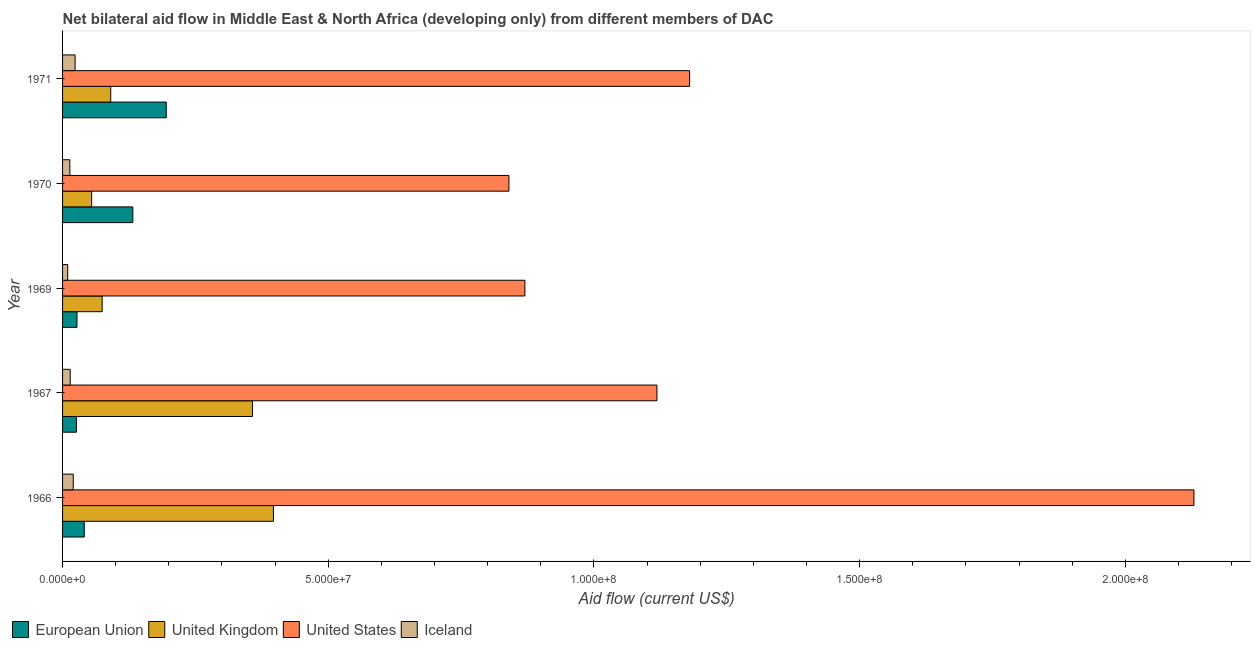How many groups of bars are there?
Make the answer very short. 5. Are the number of bars on each tick of the Y-axis equal?
Give a very brief answer. Yes. What is the label of the 2nd group of bars from the top?
Your answer should be compact. 1970. What is the amount of aid given by iceland in 1966?
Your answer should be compact. 2.01e+06. Across all years, what is the maximum amount of aid given by iceland?
Your answer should be compact. 2.36e+06. Across all years, what is the minimum amount of aid given by uk?
Your response must be concise. 5.47e+06. What is the total amount of aid given by us in the graph?
Provide a short and direct response. 6.14e+08. What is the difference between the amount of aid given by us in 1967 and that in 1969?
Give a very brief answer. 2.48e+07. What is the difference between the amount of aid given by us in 1969 and the amount of aid given by eu in 1971?
Your answer should be very brief. 6.75e+07. What is the average amount of aid given by us per year?
Ensure brevity in your answer.  1.23e+08. In the year 1971, what is the difference between the amount of aid given by uk and amount of aid given by eu?
Your answer should be compact. -1.04e+07. What is the ratio of the amount of aid given by uk in 1967 to that in 1969?
Offer a terse response. 4.8. Is the difference between the amount of aid given by eu in 1967 and 1970 greater than the difference between the amount of aid given by iceland in 1967 and 1970?
Offer a very short reply. No. What is the difference between the highest and the second highest amount of aid given by us?
Provide a succinct answer. 9.49e+07. What is the difference between the highest and the lowest amount of aid given by iceland?
Ensure brevity in your answer.  1.39e+06. Is it the case that in every year, the sum of the amount of aid given by eu and amount of aid given by uk is greater than the sum of amount of aid given by us and amount of aid given by iceland?
Your answer should be very brief. Yes. Is it the case that in every year, the sum of the amount of aid given by eu and amount of aid given by uk is greater than the amount of aid given by us?
Your answer should be very brief. No. How many bars are there?
Provide a succinct answer. 20. How are the legend labels stacked?
Provide a short and direct response. Horizontal. What is the title of the graph?
Provide a short and direct response. Net bilateral aid flow in Middle East & North Africa (developing only) from different members of DAC. Does "UNHCR" appear as one of the legend labels in the graph?
Your response must be concise. No. What is the label or title of the Y-axis?
Your response must be concise. Year. What is the Aid flow (current US$) in European Union in 1966?
Offer a terse response. 4.08e+06. What is the Aid flow (current US$) of United Kingdom in 1966?
Provide a succinct answer. 3.97e+07. What is the Aid flow (current US$) in United States in 1966?
Make the answer very short. 2.13e+08. What is the Aid flow (current US$) of Iceland in 1966?
Keep it short and to the point. 2.01e+06. What is the Aid flow (current US$) in European Union in 1967?
Provide a succinct answer. 2.62e+06. What is the Aid flow (current US$) in United Kingdom in 1967?
Make the answer very short. 3.57e+07. What is the Aid flow (current US$) of United States in 1967?
Your answer should be compact. 1.12e+08. What is the Aid flow (current US$) of Iceland in 1967?
Provide a succinct answer. 1.44e+06. What is the Aid flow (current US$) of European Union in 1969?
Make the answer very short. 2.71e+06. What is the Aid flow (current US$) in United Kingdom in 1969?
Your answer should be compact. 7.45e+06. What is the Aid flow (current US$) of United States in 1969?
Offer a terse response. 8.70e+07. What is the Aid flow (current US$) in Iceland in 1969?
Provide a short and direct response. 9.70e+05. What is the Aid flow (current US$) in European Union in 1970?
Your answer should be compact. 1.32e+07. What is the Aid flow (current US$) in United Kingdom in 1970?
Provide a succinct answer. 5.47e+06. What is the Aid flow (current US$) of United States in 1970?
Give a very brief answer. 8.40e+07. What is the Aid flow (current US$) in Iceland in 1970?
Your answer should be compact. 1.37e+06. What is the Aid flow (current US$) in European Union in 1971?
Provide a short and direct response. 1.95e+07. What is the Aid flow (current US$) in United Kingdom in 1971?
Offer a very short reply. 9.06e+06. What is the Aid flow (current US$) of United States in 1971?
Keep it short and to the point. 1.18e+08. What is the Aid flow (current US$) in Iceland in 1971?
Ensure brevity in your answer.  2.36e+06. Across all years, what is the maximum Aid flow (current US$) in European Union?
Give a very brief answer. 1.95e+07. Across all years, what is the maximum Aid flow (current US$) in United Kingdom?
Ensure brevity in your answer.  3.97e+07. Across all years, what is the maximum Aid flow (current US$) of United States?
Ensure brevity in your answer.  2.13e+08. Across all years, what is the maximum Aid flow (current US$) of Iceland?
Your answer should be compact. 2.36e+06. Across all years, what is the minimum Aid flow (current US$) of European Union?
Make the answer very short. 2.62e+06. Across all years, what is the minimum Aid flow (current US$) in United Kingdom?
Offer a very short reply. 5.47e+06. Across all years, what is the minimum Aid flow (current US$) in United States?
Your answer should be compact. 8.40e+07. Across all years, what is the minimum Aid flow (current US$) in Iceland?
Give a very brief answer. 9.70e+05. What is the total Aid flow (current US$) in European Union in the graph?
Ensure brevity in your answer.  4.21e+07. What is the total Aid flow (current US$) of United Kingdom in the graph?
Provide a succinct answer. 9.74e+07. What is the total Aid flow (current US$) in United States in the graph?
Your response must be concise. 6.14e+08. What is the total Aid flow (current US$) in Iceland in the graph?
Provide a short and direct response. 8.15e+06. What is the difference between the Aid flow (current US$) of European Union in 1966 and that in 1967?
Provide a short and direct response. 1.46e+06. What is the difference between the Aid flow (current US$) in United Kingdom in 1966 and that in 1967?
Offer a terse response. 3.95e+06. What is the difference between the Aid flow (current US$) in United States in 1966 and that in 1967?
Keep it short and to the point. 1.01e+08. What is the difference between the Aid flow (current US$) of Iceland in 1966 and that in 1967?
Give a very brief answer. 5.70e+05. What is the difference between the Aid flow (current US$) of European Union in 1966 and that in 1969?
Provide a short and direct response. 1.37e+06. What is the difference between the Aid flow (current US$) in United Kingdom in 1966 and that in 1969?
Make the answer very short. 3.22e+07. What is the difference between the Aid flow (current US$) of United States in 1966 and that in 1969?
Offer a terse response. 1.26e+08. What is the difference between the Aid flow (current US$) in Iceland in 1966 and that in 1969?
Make the answer very short. 1.04e+06. What is the difference between the Aid flow (current US$) of European Union in 1966 and that in 1970?
Ensure brevity in your answer.  -9.14e+06. What is the difference between the Aid flow (current US$) in United Kingdom in 1966 and that in 1970?
Keep it short and to the point. 3.42e+07. What is the difference between the Aid flow (current US$) in United States in 1966 and that in 1970?
Offer a very short reply. 1.29e+08. What is the difference between the Aid flow (current US$) in Iceland in 1966 and that in 1970?
Provide a succinct answer. 6.40e+05. What is the difference between the Aid flow (current US$) of European Union in 1966 and that in 1971?
Make the answer very short. -1.54e+07. What is the difference between the Aid flow (current US$) in United Kingdom in 1966 and that in 1971?
Your answer should be very brief. 3.06e+07. What is the difference between the Aid flow (current US$) in United States in 1966 and that in 1971?
Provide a succinct answer. 9.49e+07. What is the difference between the Aid flow (current US$) of Iceland in 1966 and that in 1971?
Offer a very short reply. -3.50e+05. What is the difference between the Aid flow (current US$) in European Union in 1967 and that in 1969?
Give a very brief answer. -9.00e+04. What is the difference between the Aid flow (current US$) in United Kingdom in 1967 and that in 1969?
Your response must be concise. 2.83e+07. What is the difference between the Aid flow (current US$) of United States in 1967 and that in 1969?
Offer a very short reply. 2.48e+07. What is the difference between the Aid flow (current US$) of European Union in 1967 and that in 1970?
Make the answer very short. -1.06e+07. What is the difference between the Aid flow (current US$) in United Kingdom in 1967 and that in 1970?
Keep it short and to the point. 3.03e+07. What is the difference between the Aid flow (current US$) in United States in 1967 and that in 1970?
Keep it short and to the point. 2.78e+07. What is the difference between the Aid flow (current US$) of Iceland in 1967 and that in 1970?
Offer a very short reply. 7.00e+04. What is the difference between the Aid flow (current US$) in European Union in 1967 and that in 1971?
Ensure brevity in your answer.  -1.69e+07. What is the difference between the Aid flow (current US$) in United Kingdom in 1967 and that in 1971?
Your answer should be compact. 2.67e+07. What is the difference between the Aid flow (current US$) of United States in 1967 and that in 1971?
Provide a short and direct response. -6.15e+06. What is the difference between the Aid flow (current US$) in Iceland in 1967 and that in 1971?
Your response must be concise. -9.20e+05. What is the difference between the Aid flow (current US$) of European Union in 1969 and that in 1970?
Ensure brevity in your answer.  -1.05e+07. What is the difference between the Aid flow (current US$) in United Kingdom in 1969 and that in 1970?
Give a very brief answer. 1.98e+06. What is the difference between the Aid flow (current US$) of United States in 1969 and that in 1970?
Make the answer very short. 3.00e+06. What is the difference between the Aid flow (current US$) in Iceland in 1969 and that in 1970?
Give a very brief answer. -4.00e+05. What is the difference between the Aid flow (current US$) of European Union in 1969 and that in 1971?
Ensure brevity in your answer.  -1.68e+07. What is the difference between the Aid flow (current US$) of United Kingdom in 1969 and that in 1971?
Your answer should be very brief. -1.61e+06. What is the difference between the Aid flow (current US$) of United States in 1969 and that in 1971?
Your answer should be compact. -3.10e+07. What is the difference between the Aid flow (current US$) in Iceland in 1969 and that in 1971?
Provide a short and direct response. -1.39e+06. What is the difference between the Aid flow (current US$) of European Union in 1970 and that in 1971?
Your response must be concise. -6.29e+06. What is the difference between the Aid flow (current US$) of United Kingdom in 1970 and that in 1971?
Make the answer very short. -3.59e+06. What is the difference between the Aid flow (current US$) in United States in 1970 and that in 1971?
Your answer should be compact. -3.40e+07. What is the difference between the Aid flow (current US$) in Iceland in 1970 and that in 1971?
Keep it short and to the point. -9.90e+05. What is the difference between the Aid flow (current US$) in European Union in 1966 and the Aid flow (current US$) in United Kingdom in 1967?
Your answer should be compact. -3.16e+07. What is the difference between the Aid flow (current US$) of European Union in 1966 and the Aid flow (current US$) of United States in 1967?
Your answer should be compact. -1.08e+08. What is the difference between the Aid flow (current US$) of European Union in 1966 and the Aid flow (current US$) of Iceland in 1967?
Your answer should be very brief. 2.64e+06. What is the difference between the Aid flow (current US$) in United Kingdom in 1966 and the Aid flow (current US$) in United States in 1967?
Your response must be concise. -7.22e+07. What is the difference between the Aid flow (current US$) of United Kingdom in 1966 and the Aid flow (current US$) of Iceland in 1967?
Offer a very short reply. 3.82e+07. What is the difference between the Aid flow (current US$) of United States in 1966 and the Aid flow (current US$) of Iceland in 1967?
Provide a short and direct response. 2.11e+08. What is the difference between the Aid flow (current US$) of European Union in 1966 and the Aid flow (current US$) of United Kingdom in 1969?
Provide a succinct answer. -3.37e+06. What is the difference between the Aid flow (current US$) of European Union in 1966 and the Aid flow (current US$) of United States in 1969?
Ensure brevity in your answer.  -8.29e+07. What is the difference between the Aid flow (current US$) in European Union in 1966 and the Aid flow (current US$) in Iceland in 1969?
Offer a very short reply. 3.11e+06. What is the difference between the Aid flow (current US$) in United Kingdom in 1966 and the Aid flow (current US$) in United States in 1969?
Offer a very short reply. -4.73e+07. What is the difference between the Aid flow (current US$) of United Kingdom in 1966 and the Aid flow (current US$) of Iceland in 1969?
Offer a terse response. 3.87e+07. What is the difference between the Aid flow (current US$) of United States in 1966 and the Aid flow (current US$) of Iceland in 1969?
Offer a terse response. 2.12e+08. What is the difference between the Aid flow (current US$) of European Union in 1966 and the Aid flow (current US$) of United Kingdom in 1970?
Make the answer very short. -1.39e+06. What is the difference between the Aid flow (current US$) in European Union in 1966 and the Aid flow (current US$) in United States in 1970?
Provide a succinct answer. -7.99e+07. What is the difference between the Aid flow (current US$) in European Union in 1966 and the Aid flow (current US$) in Iceland in 1970?
Your answer should be very brief. 2.71e+06. What is the difference between the Aid flow (current US$) in United Kingdom in 1966 and the Aid flow (current US$) in United States in 1970?
Give a very brief answer. -4.43e+07. What is the difference between the Aid flow (current US$) in United Kingdom in 1966 and the Aid flow (current US$) in Iceland in 1970?
Offer a terse response. 3.83e+07. What is the difference between the Aid flow (current US$) of United States in 1966 and the Aid flow (current US$) of Iceland in 1970?
Give a very brief answer. 2.12e+08. What is the difference between the Aid flow (current US$) of European Union in 1966 and the Aid flow (current US$) of United Kingdom in 1971?
Offer a very short reply. -4.98e+06. What is the difference between the Aid flow (current US$) in European Union in 1966 and the Aid flow (current US$) in United States in 1971?
Offer a very short reply. -1.14e+08. What is the difference between the Aid flow (current US$) of European Union in 1966 and the Aid flow (current US$) of Iceland in 1971?
Offer a terse response. 1.72e+06. What is the difference between the Aid flow (current US$) in United Kingdom in 1966 and the Aid flow (current US$) in United States in 1971?
Provide a short and direct response. -7.83e+07. What is the difference between the Aid flow (current US$) of United Kingdom in 1966 and the Aid flow (current US$) of Iceland in 1971?
Make the answer very short. 3.73e+07. What is the difference between the Aid flow (current US$) in United States in 1966 and the Aid flow (current US$) in Iceland in 1971?
Provide a succinct answer. 2.11e+08. What is the difference between the Aid flow (current US$) of European Union in 1967 and the Aid flow (current US$) of United Kingdom in 1969?
Make the answer very short. -4.83e+06. What is the difference between the Aid flow (current US$) in European Union in 1967 and the Aid flow (current US$) in United States in 1969?
Offer a very short reply. -8.44e+07. What is the difference between the Aid flow (current US$) in European Union in 1967 and the Aid flow (current US$) in Iceland in 1969?
Keep it short and to the point. 1.65e+06. What is the difference between the Aid flow (current US$) in United Kingdom in 1967 and the Aid flow (current US$) in United States in 1969?
Provide a short and direct response. -5.13e+07. What is the difference between the Aid flow (current US$) of United Kingdom in 1967 and the Aid flow (current US$) of Iceland in 1969?
Provide a short and direct response. 3.48e+07. What is the difference between the Aid flow (current US$) of United States in 1967 and the Aid flow (current US$) of Iceland in 1969?
Provide a succinct answer. 1.11e+08. What is the difference between the Aid flow (current US$) in European Union in 1967 and the Aid flow (current US$) in United Kingdom in 1970?
Your response must be concise. -2.85e+06. What is the difference between the Aid flow (current US$) in European Union in 1967 and the Aid flow (current US$) in United States in 1970?
Ensure brevity in your answer.  -8.14e+07. What is the difference between the Aid flow (current US$) of European Union in 1967 and the Aid flow (current US$) of Iceland in 1970?
Offer a very short reply. 1.25e+06. What is the difference between the Aid flow (current US$) in United Kingdom in 1967 and the Aid flow (current US$) in United States in 1970?
Your answer should be very brief. -4.83e+07. What is the difference between the Aid flow (current US$) in United Kingdom in 1967 and the Aid flow (current US$) in Iceland in 1970?
Provide a succinct answer. 3.44e+07. What is the difference between the Aid flow (current US$) in United States in 1967 and the Aid flow (current US$) in Iceland in 1970?
Give a very brief answer. 1.10e+08. What is the difference between the Aid flow (current US$) in European Union in 1967 and the Aid flow (current US$) in United Kingdom in 1971?
Keep it short and to the point. -6.44e+06. What is the difference between the Aid flow (current US$) of European Union in 1967 and the Aid flow (current US$) of United States in 1971?
Your answer should be compact. -1.15e+08. What is the difference between the Aid flow (current US$) in European Union in 1967 and the Aid flow (current US$) in Iceland in 1971?
Ensure brevity in your answer.  2.60e+05. What is the difference between the Aid flow (current US$) of United Kingdom in 1967 and the Aid flow (current US$) of United States in 1971?
Offer a very short reply. -8.23e+07. What is the difference between the Aid flow (current US$) of United Kingdom in 1967 and the Aid flow (current US$) of Iceland in 1971?
Provide a short and direct response. 3.34e+07. What is the difference between the Aid flow (current US$) in United States in 1967 and the Aid flow (current US$) in Iceland in 1971?
Your response must be concise. 1.09e+08. What is the difference between the Aid flow (current US$) in European Union in 1969 and the Aid flow (current US$) in United Kingdom in 1970?
Give a very brief answer. -2.76e+06. What is the difference between the Aid flow (current US$) of European Union in 1969 and the Aid flow (current US$) of United States in 1970?
Provide a short and direct response. -8.13e+07. What is the difference between the Aid flow (current US$) of European Union in 1969 and the Aid flow (current US$) of Iceland in 1970?
Your answer should be very brief. 1.34e+06. What is the difference between the Aid flow (current US$) in United Kingdom in 1969 and the Aid flow (current US$) in United States in 1970?
Offer a terse response. -7.66e+07. What is the difference between the Aid flow (current US$) in United Kingdom in 1969 and the Aid flow (current US$) in Iceland in 1970?
Offer a very short reply. 6.08e+06. What is the difference between the Aid flow (current US$) of United States in 1969 and the Aid flow (current US$) of Iceland in 1970?
Your answer should be very brief. 8.56e+07. What is the difference between the Aid flow (current US$) in European Union in 1969 and the Aid flow (current US$) in United Kingdom in 1971?
Your answer should be very brief. -6.35e+06. What is the difference between the Aid flow (current US$) of European Union in 1969 and the Aid flow (current US$) of United States in 1971?
Give a very brief answer. -1.15e+08. What is the difference between the Aid flow (current US$) of European Union in 1969 and the Aid flow (current US$) of Iceland in 1971?
Your answer should be compact. 3.50e+05. What is the difference between the Aid flow (current US$) in United Kingdom in 1969 and the Aid flow (current US$) in United States in 1971?
Ensure brevity in your answer.  -1.11e+08. What is the difference between the Aid flow (current US$) in United Kingdom in 1969 and the Aid flow (current US$) in Iceland in 1971?
Give a very brief answer. 5.09e+06. What is the difference between the Aid flow (current US$) in United States in 1969 and the Aid flow (current US$) in Iceland in 1971?
Keep it short and to the point. 8.46e+07. What is the difference between the Aid flow (current US$) in European Union in 1970 and the Aid flow (current US$) in United Kingdom in 1971?
Make the answer very short. 4.16e+06. What is the difference between the Aid flow (current US$) of European Union in 1970 and the Aid flow (current US$) of United States in 1971?
Offer a terse response. -1.05e+08. What is the difference between the Aid flow (current US$) of European Union in 1970 and the Aid flow (current US$) of Iceland in 1971?
Your answer should be compact. 1.09e+07. What is the difference between the Aid flow (current US$) of United Kingdom in 1970 and the Aid flow (current US$) of United States in 1971?
Your response must be concise. -1.13e+08. What is the difference between the Aid flow (current US$) in United Kingdom in 1970 and the Aid flow (current US$) in Iceland in 1971?
Provide a succinct answer. 3.11e+06. What is the difference between the Aid flow (current US$) of United States in 1970 and the Aid flow (current US$) of Iceland in 1971?
Your answer should be very brief. 8.16e+07. What is the average Aid flow (current US$) of European Union per year?
Offer a terse response. 8.43e+06. What is the average Aid flow (current US$) in United Kingdom per year?
Offer a very short reply. 1.95e+07. What is the average Aid flow (current US$) in United States per year?
Provide a short and direct response. 1.23e+08. What is the average Aid flow (current US$) in Iceland per year?
Make the answer very short. 1.63e+06. In the year 1966, what is the difference between the Aid flow (current US$) of European Union and Aid flow (current US$) of United Kingdom?
Keep it short and to the point. -3.56e+07. In the year 1966, what is the difference between the Aid flow (current US$) of European Union and Aid flow (current US$) of United States?
Your answer should be very brief. -2.09e+08. In the year 1966, what is the difference between the Aid flow (current US$) in European Union and Aid flow (current US$) in Iceland?
Provide a short and direct response. 2.07e+06. In the year 1966, what is the difference between the Aid flow (current US$) of United Kingdom and Aid flow (current US$) of United States?
Make the answer very short. -1.73e+08. In the year 1966, what is the difference between the Aid flow (current US$) in United Kingdom and Aid flow (current US$) in Iceland?
Keep it short and to the point. 3.77e+07. In the year 1966, what is the difference between the Aid flow (current US$) in United States and Aid flow (current US$) in Iceland?
Provide a succinct answer. 2.11e+08. In the year 1967, what is the difference between the Aid flow (current US$) in European Union and Aid flow (current US$) in United Kingdom?
Your response must be concise. -3.31e+07. In the year 1967, what is the difference between the Aid flow (current US$) of European Union and Aid flow (current US$) of United States?
Keep it short and to the point. -1.09e+08. In the year 1967, what is the difference between the Aid flow (current US$) in European Union and Aid flow (current US$) in Iceland?
Your answer should be very brief. 1.18e+06. In the year 1967, what is the difference between the Aid flow (current US$) of United Kingdom and Aid flow (current US$) of United States?
Your answer should be very brief. -7.61e+07. In the year 1967, what is the difference between the Aid flow (current US$) of United Kingdom and Aid flow (current US$) of Iceland?
Your answer should be very brief. 3.43e+07. In the year 1967, what is the difference between the Aid flow (current US$) of United States and Aid flow (current US$) of Iceland?
Provide a succinct answer. 1.10e+08. In the year 1969, what is the difference between the Aid flow (current US$) in European Union and Aid flow (current US$) in United Kingdom?
Offer a very short reply. -4.74e+06. In the year 1969, what is the difference between the Aid flow (current US$) in European Union and Aid flow (current US$) in United States?
Make the answer very short. -8.43e+07. In the year 1969, what is the difference between the Aid flow (current US$) in European Union and Aid flow (current US$) in Iceland?
Ensure brevity in your answer.  1.74e+06. In the year 1969, what is the difference between the Aid flow (current US$) of United Kingdom and Aid flow (current US$) of United States?
Provide a short and direct response. -7.96e+07. In the year 1969, what is the difference between the Aid flow (current US$) of United Kingdom and Aid flow (current US$) of Iceland?
Provide a short and direct response. 6.48e+06. In the year 1969, what is the difference between the Aid flow (current US$) of United States and Aid flow (current US$) of Iceland?
Your answer should be very brief. 8.60e+07. In the year 1970, what is the difference between the Aid flow (current US$) of European Union and Aid flow (current US$) of United Kingdom?
Your answer should be compact. 7.75e+06. In the year 1970, what is the difference between the Aid flow (current US$) of European Union and Aid flow (current US$) of United States?
Provide a short and direct response. -7.08e+07. In the year 1970, what is the difference between the Aid flow (current US$) of European Union and Aid flow (current US$) of Iceland?
Your answer should be compact. 1.18e+07. In the year 1970, what is the difference between the Aid flow (current US$) of United Kingdom and Aid flow (current US$) of United States?
Your answer should be compact. -7.85e+07. In the year 1970, what is the difference between the Aid flow (current US$) in United Kingdom and Aid flow (current US$) in Iceland?
Offer a very short reply. 4.10e+06. In the year 1970, what is the difference between the Aid flow (current US$) in United States and Aid flow (current US$) in Iceland?
Your response must be concise. 8.26e+07. In the year 1971, what is the difference between the Aid flow (current US$) of European Union and Aid flow (current US$) of United Kingdom?
Your answer should be compact. 1.04e+07. In the year 1971, what is the difference between the Aid flow (current US$) of European Union and Aid flow (current US$) of United States?
Your answer should be compact. -9.85e+07. In the year 1971, what is the difference between the Aid flow (current US$) in European Union and Aid flow (current US$) in Iceland?
Give a very brief answer. 1.72e+07. In the year 1971, what is the difference between the Aid flow (current US$) of United Kingdom and Aid flow (current US$) of United States?
Offer a very short reply. -1.09e+08. In the year 1971, what is the difference between the Aid flow (current US$) in United Kingdom and Aid flow (current US$) in Iceland?
Offer a very short reply. 6.70e+06. In the year 1971, what is the difference between the Aid flow (current US$) in United States and Aid flow (current US$) in Iceland?
Your answer should be compact. 1.16e+08. What is the ratio of the Aid flow (current US$) in European Union in 1966 to that in 1967?
Make the answer very short. 1.56. What is the ratio of the Aid flow (current US$) in United Kingdom in 1966 to that in 1967?
Your response must be concise. 1.11. What is the ratio of the Aid flow (current US$) of United States in 1966 to that in 1967?
Ensure brevity in your answer.  1.9. What is the ratio of the Aid flow (current US$) of Iceland in 1966 to that in 1967?
Give a very brief answer. 1.4. What is the ratio of the Aid flow (current US$) in European Union in 1966 to that in 1969?
Provide a succinct answer. 1.51. What is the ratio of the Aid flow (current US$) of United Kingdom in 1966 to that in 1969?
Offer a terse response. 5.33. What is the ratio of the Aid flow (current US$) of United States in 1966 to that in 1969?
Offer a very short reply. 2.45. What is the ratio of the Aid flow (current US$) in Iceland in 1966 to that in 1969?
Keep it short and to the point. 2.07. What is the ratio of the Aid flow (current US$) in European Union in 1966 to that in 1970?
Provide a short and direct response. 0.31. What is the ratio of the Aid flow (current US$) in United Kingdom in 1966 to that in 1970?
Give a very brief answer. 7.25. What is the ratio of the Aid flow (current US$) of United States in 1966 to that in 1970?
Make the answer very short. 2.53. What is the ratio of the Aid flow (current US$) in Iceland in 1966 to that in 1970?
Provide a succinct answer. 1.47. What is the ratio of the Aid flow (current US$) of European Union in 1966 to that in 1971?
Ensure brevity in your answer.  0.21. What is the ratio of the Aid flow (current US$) of United Kingdom in 1966 to that in 1971?
Your answer should be very brief. 4.38. What is the ratio of the Aid flow (current US$) in United States in 1966 to that in 1971?
Provide a short and direct response. 1.8. What is the ratio of the Aid flow (current US$) of Iceland in 1966 to that in 1971?
Keep it short and to the point. 0.85. What is the ratio of the Aid flow (current US$) in European Union in 1967 to that in 1969?
Provide a succinct answer. 0.97. What is the ratio of the Aid flow (current US$) in United Kingdom in 1967 to that in 1969?
Give a very brief answer. 4.8. What is the ratio of the Aid flow (current US$) in United States in 1967 to that in 1969?
Make the answer very short. 1.29. What is the ratio of the Aid flow (current US$) in Iceland in 1967 to that in 1969?
Give a very brief answer. 1.48. What is the ratio of the Aid flow (current US$) of European Union in 1967 to that in 1970?
Provide a short and direct response. 0.2. What is the ratio of the Aid flow (current US$) of United Kingdom in 1967 to that in 1970?
Give a very brief answer. 6.53. What is the ratio of the Aid flow (current US$) of United States in 1967 to that in 1970?
Keep it short and to the point. 1.33. What is the ratio of the Aid flow (current US$) of Iceland in 1967 to that in 1970?
Your answer should be very brief. 1.05. What is the ratio of the Aid flow (current US$) in European Union in 1967 to that in 1971?
Keep it short and to the point. 0.13. What is the ratio of the Aid flow (current US$) in United Kingdom in 1967 to that in 1971?
Your response must be concise. 3.94. What is the ratio of the Aid flow (current US$) of United States in 1967 to that in 1971?
Make the answer very short. 0.95. What is the ratio of the Aid flow (current US$) in Iceland in 1967 to that in 1971?
Make the answer very short. 0.61. What is the ratio of the Aid flow (current US$) in European Union in 1969 to that in 1970?
Keep it short and to the point. 0.2. What is the ratio of the Aid flow (current US$) in United Kingdom in 1969 to that in 1970?
Make the answer very short. 1.36. What is the ratio of the Aid flow (current US$) in United States in 1969 to that in 1970?
Your response must be concise. 1.04. What is the ratio of the Aid flow (current US$) of Iceland in 1969 to that in 1970?
Your answer should be very brief. 0.71. What is the ratio of the Aid flow (current US$) in European Union in 1969 to that in 1971?
Provide a succinct answer. 0.14. What is the ratio of the Aid flow (current US$) in United Kingdom in 1969 to that in 1971?
Your response must be concise. 0.82. What is the ratio of the Aid flow (current US$) in United States in 1969 to that in 1971?
Keep it short and to the point. 0.74. What is the ratio of the Aid flow (current US$) in Iceland in 1969 to that in 1971?
Provide a short and direct response. 0.41. What is the ratio of the Aid flow (current US$) of European Union in 1970 to that in 1971?
Ensure brevity in your answer.  0.68. What is the ratio of the Aid flow (current US$) in United Kingdom in 1970 to that in 1971?
Provide a succinct answer. 0.6. What is the ratio of the Aid flow (current US$) in United States in 1970 to that in 1971?
Provide a short and direct response. 0.71. What is the ratio of the Aid flow (current US$) of Iceland in 1970 to that in 1971?
Your answer should be very brief. 0.58. What is the difference between the highest and the second highest Aid flow (current US$) of European Union?
Make the answer very short. 6.29e+06. What is the difference between the highest and the second highest Aid flow (current US$) in United Kingdom?
Provide a short and direct response. 3.95e+06. What is the difference between the highest and the second highest Aid flow (current US$) of United States?
Make the answer very short. 9.49e+07. What is the difference between the highest and the lowest Aid flow (current US$) in European Union?
Your answer should be compact. 1.69e+07. What is the difference between the highest and the lowest Aid flow (current US$) of United Kingdom?
Provide a short and direct response. 3.42e+07. What is the difference between the highest and the lowest Aid flow (current US$) of United States?
Keep it short and to the point. 1.29e+08. What is the difference between the highest and the lowest Aid flow (current US$) of Iceland?
Give a very brief answer. 1.39e+06. 